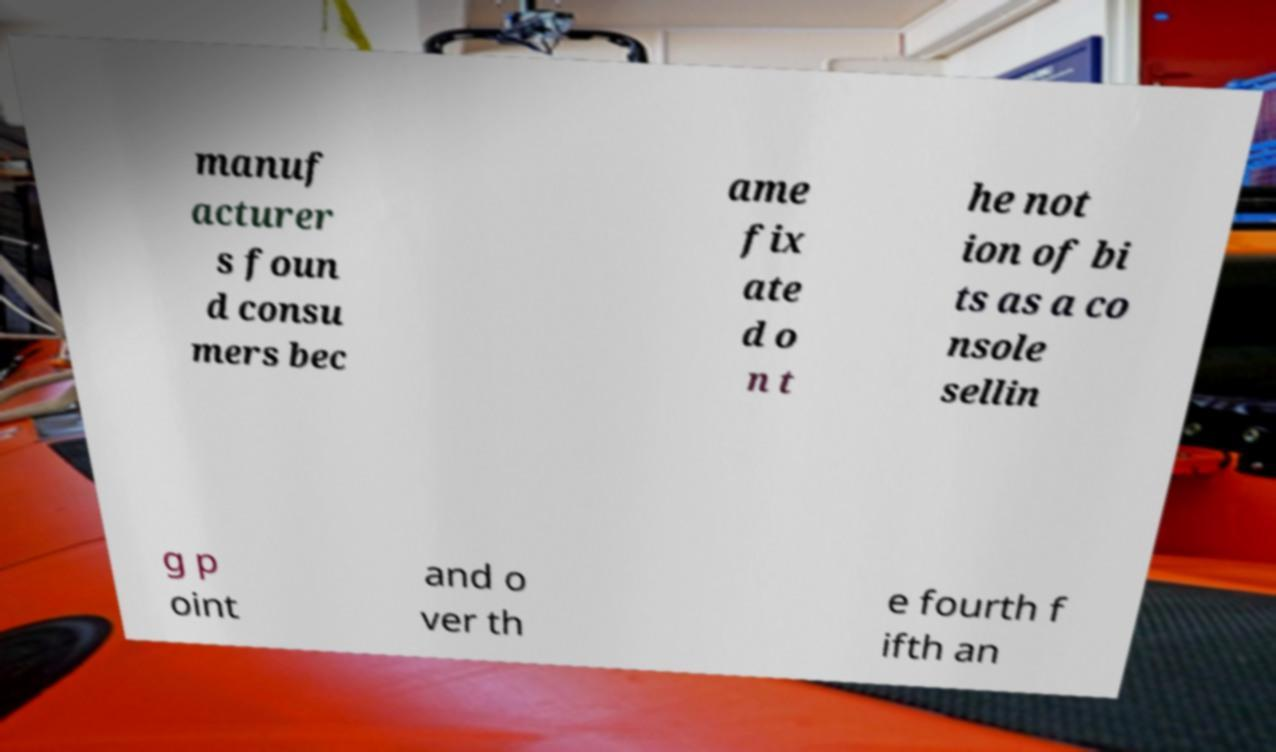Could you assist in decoding the text presented in this image and type it out clearly? manuf acturer s foun d consu mers bec ame fix ate d o n t he not ion of bi ts as a co nsole sellin g p oint and o ver th e fourth f ifth an 